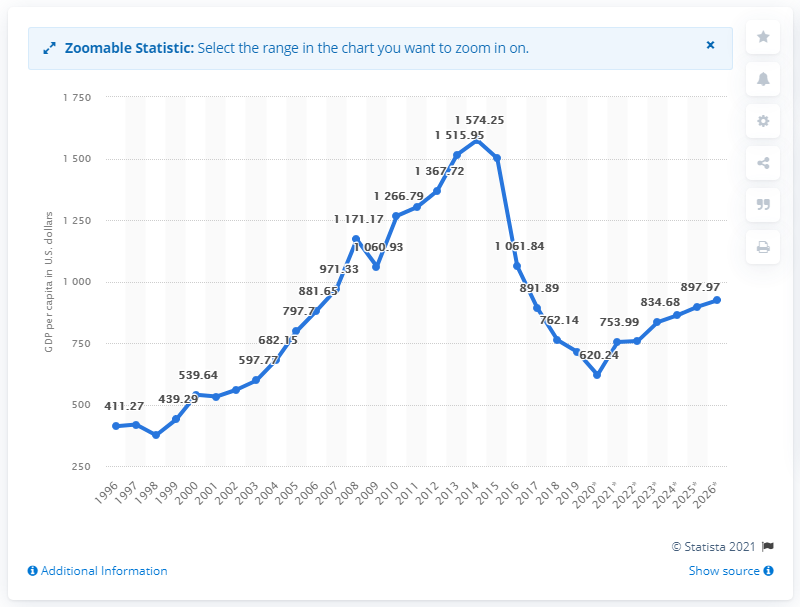Highlight a few significant elements in this photo. In 2020, the Gross Domestic Product (GDP) per capita in Yemen was estimated to be $620.24. 